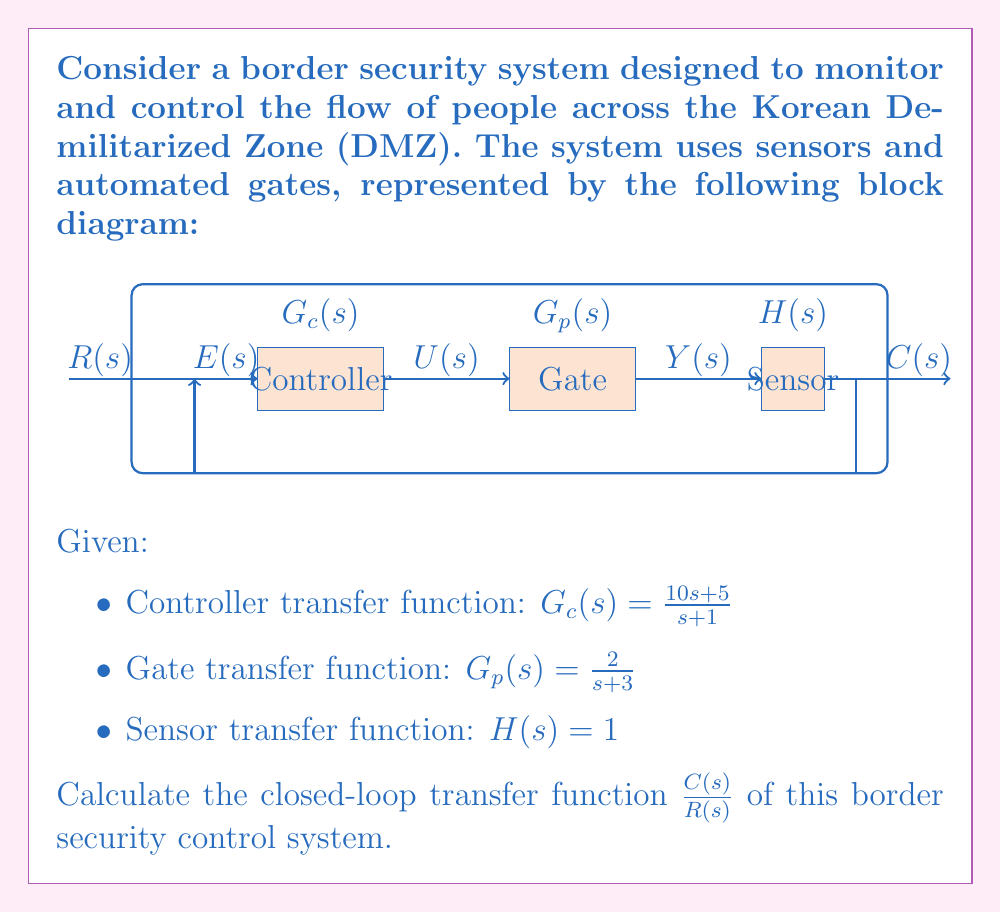Help me with this question. To solve this problem, we'll follow these steps:

1) First, let's identify the forward path gain and the feedback path gain:
   Forward path gain: $G(s) = G_c(s) \cdot G_p(s)$
   Feedback path gain: $H(s) = 1$

2) Calculate $G(s)$:
   $$G(s) = G_c(s) \cdot G_p(s) = \frac{10s + 5}{s + 1} \cdot \frac{2}{s + 3}$$
   
   $$G(s) = \frac{20s + 10}{s^2 + 4s + 3}$$

3) The closed-loop transfer function for a unity feedback system is given by:
   $$\frac{C(s)}{R(s)} = \frac{G(s)}{1 + G(s)H(s)}$$

4) Substitute the values:
   $$\frac{C(s)}{R(s)} = \frac{\frac{20s + 10}{s^2 + 4s + 3}}{1 + \frac{20s + 10}{s^2 + 4s + 3} \cdot 1}$$

5) Find a common denominator:
   $$\frac{C(s)}{R(s)} = \frac{20s + 10}{s^2 + 4s + 3 + 20s + 10}$$

6) Simplify:
   $$\frac{C(s)}{R(s)} = \frac{20s + 10}{s^2 + 24s + 13}$$

This is the closed-loop transfer function of the border security control system.
Answer: $$\frac{C(s)}{R(s)} = \frac{20s + 10}{s^2 + 24s + 13}$$ 